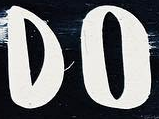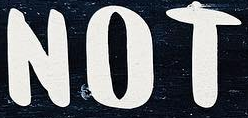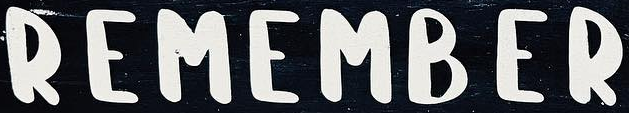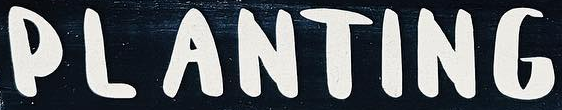What text appears in these images from left to right, separated by a semicolon? DO; NOT; REMAMBER; PLANTING 